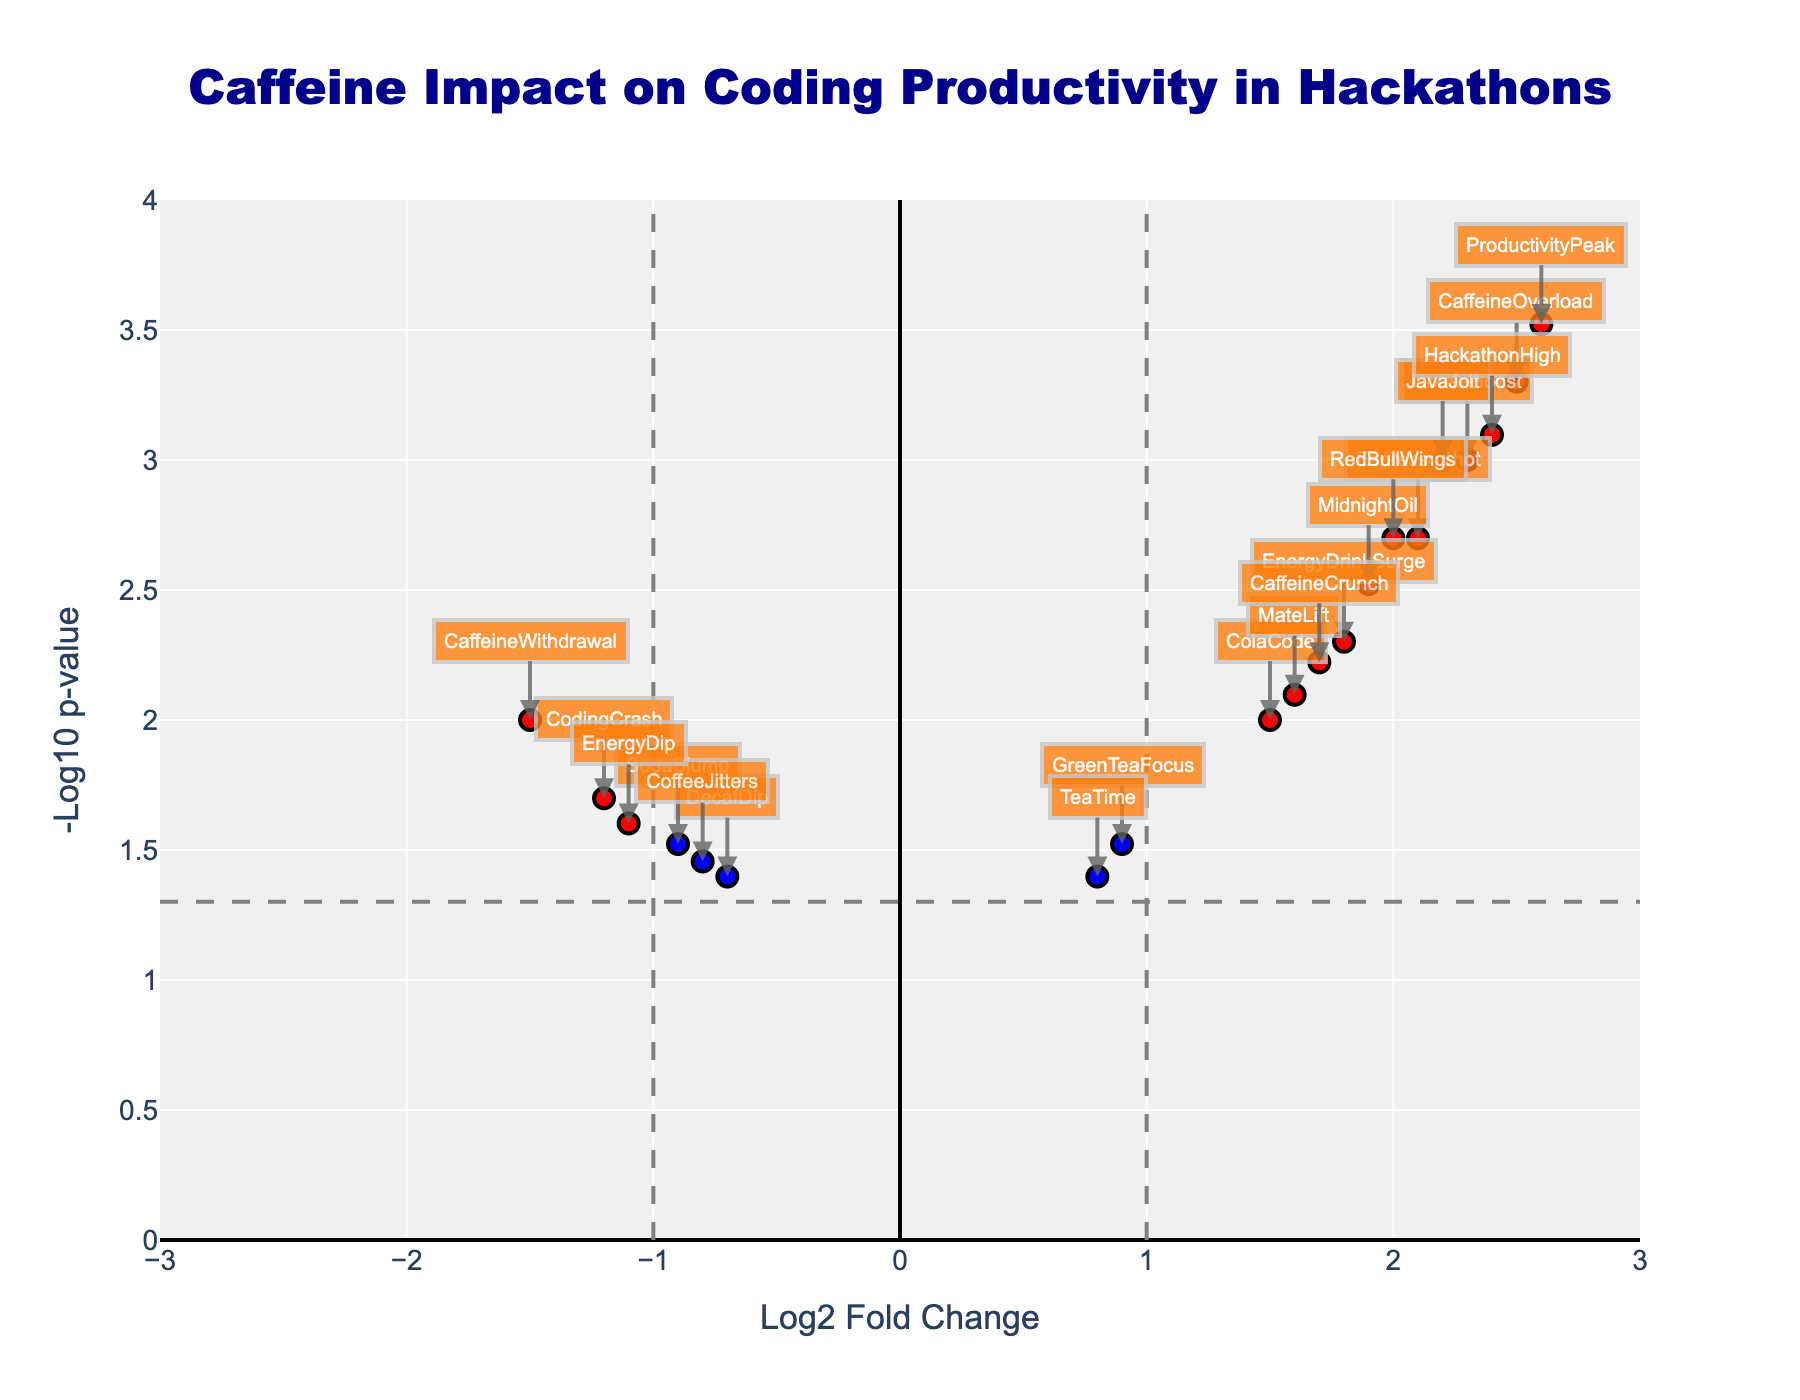How many red data points are there in the plot? To find the number of red data points, we need to look for all points colored red in the plot. These points represent significant differences with a log2 fold change above the threshold and a p-value below the threshold.
Answer: 13 What range does the x-axis cover? The x-axis of the plot represents the Log2 Fold Change and is marked with a range that spans from -3 to 3.
Answer: -3 to 3 Which caffeine type has the highest -log10(p-value)? To find the caffeine type with the highest -log10(p-value), we look for the point that reaches the highest on the y-axis. This corresponds to the lowest p-value as -log10 transformation inverts the relationship.
Answer: ProductivityPeak How many data points fall below the p-value threshold but do not exceed the fold-change threshold? These data points are colored blue in the plot, representing significant p-values but not significant Log2 Fold Changes. Count the number of blue points.
Answer: 2 What is the significance threshold for p-values? The p-value threshold is reflected by the horizontal dashed line, and this line corresponds to where -log10(p-value) is calculated. Inspecting the line, we can infer the p-value threshold.
Answer: 0.05 Which caffeinated items did not have a significant impact on productivity? Among the grey-colored data points, these data points indicate insignificant impacts because they did not meet either the Log2 Fold Change threshold or the p-value threshold.
Answer: DecafDip, TeaTime, SodaSlump, CoffeeJitters, EnergyDip Which of the significant caffeinated items had the lowest Log2 Fold Change and what was its -log10(p-value)? To answer this, we examine the red or blue points for the one having the smallest Log2 Fold Change. In this case, it looks like a red data point, CodingCrash, with its values presented in the hover text.
Answer: CodingCrash, -1.2, ~1.70 What is the median -log10(p-value) for all data points with Log2 Fold Change greater than 2? First, identify the y-values (i.e., -log10(p-value)) for all data points with a Log2 Fold Change greater than 2. Then, compute the median value of these points. Points meeting this criterion are CoffeeBoost, EspressoShot, CaffeineOverload, JavaJolt, HackathonHigh, ProductivityPeak. Median of their -log10(p-value) values (~3, ~2.7, ~3.3, ~3, ~3.1, ~3.5).
Answer: ~3.1 